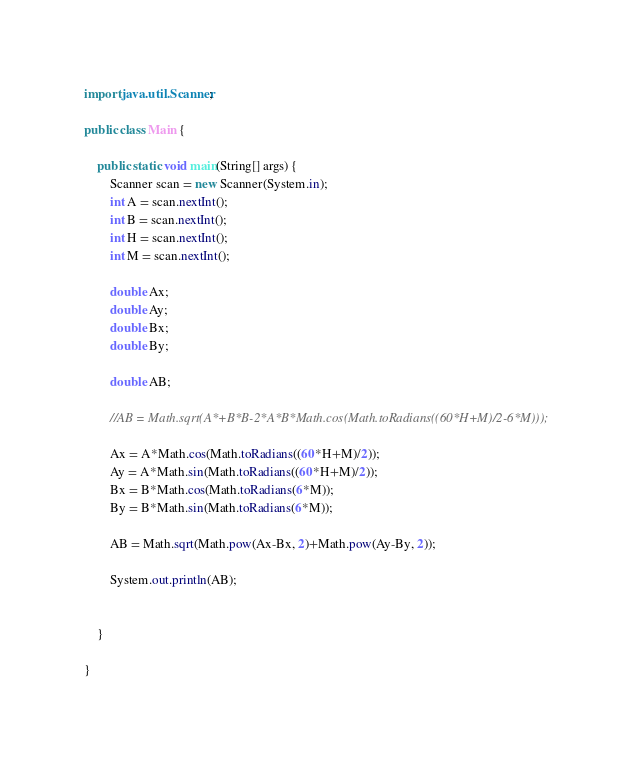Convert code to text. <code><loc_0><loc_0><loc_500><loc_500><_Java_>import java.util.Scanner;

public class Main {

	public static void main(String[] args) {
		Scanner scan = new Scanner(System.in);
		int A = scan.nextInt();
		int B = scan.nextInt();
		int H = scan.nextInt();
		int M = scan.nextInt();
		
		double Ax;
		double Ay;
		double Bx;
		double By;
		
		double AB;
		
		//AB = Math.sqrt(A*+B*B-2*A*B*Math.cos(Math.toRadians((60*H+M)/2-6*M)));
		
		Ax = A*Math.cos(Math.toRadians((60*H+M)/2));
		Ay = A*Math.sin(Math.toRadians((60*H+M)/2));
		Bx = B*Math.cos(Math.toRadians(6*M));
		By = B*Math.sin(Math.toRadians(6*M));
		
		AB = Math.sqrt(Math.pow(Ax-Bx, 2)+Math.pow(Ay-By, 2));
			
		System.out.println(AB);


	}

}
</code> 